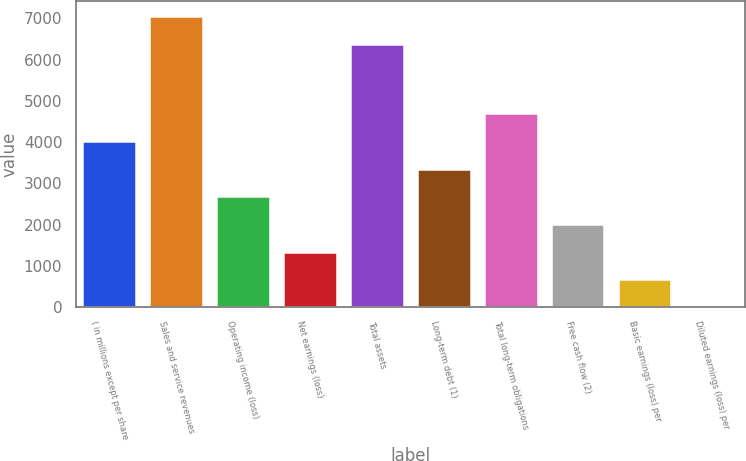<chart> <loc_0><loc_0><loc_500><loc_500><bar_chart><fcel>( in millions except per share<fcel>Sales and service revenues<fcel>Operating income (loss)<fcel>Net earnings (loss)<fcel>Total assets<fcel>Long-term debt (1)<fcel>Total long-term obligations<fcel>Free cash flow (2)<fcel>Basic earnings (loss) per<fcel>Diluted earnings (loss) per<nl><fcel>4025.97<fcel>7062.51<fcel>2684.95<fcel>1343.93<fcel>6392<fcel>3355.46<fcel>4696.48<fcel>2014.44<fcel>673.42<fcel>2.91<nl></chart> 